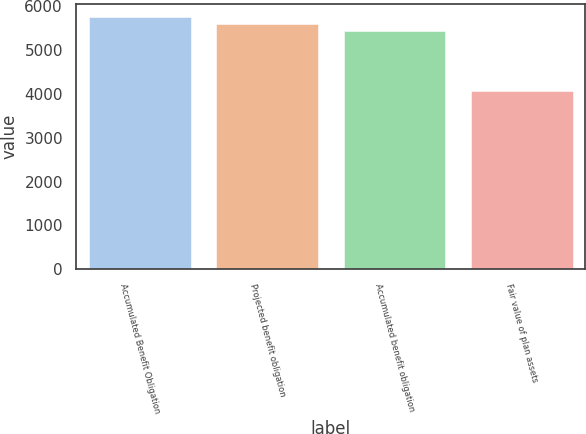Convert chart to OTSL. <chart><loc_0><loc_0><loc_500><loc_500><bar_chart><fcel>Accumulated Benefit Obligation<fcel>Projected benefit obligation<fcel>Accumulated benefit obligation<fcel>Fair value of plan assets<nl><fcel>5753.4<fcel>5588.2<fcel>5423<fcel>4072<nl></chart> 